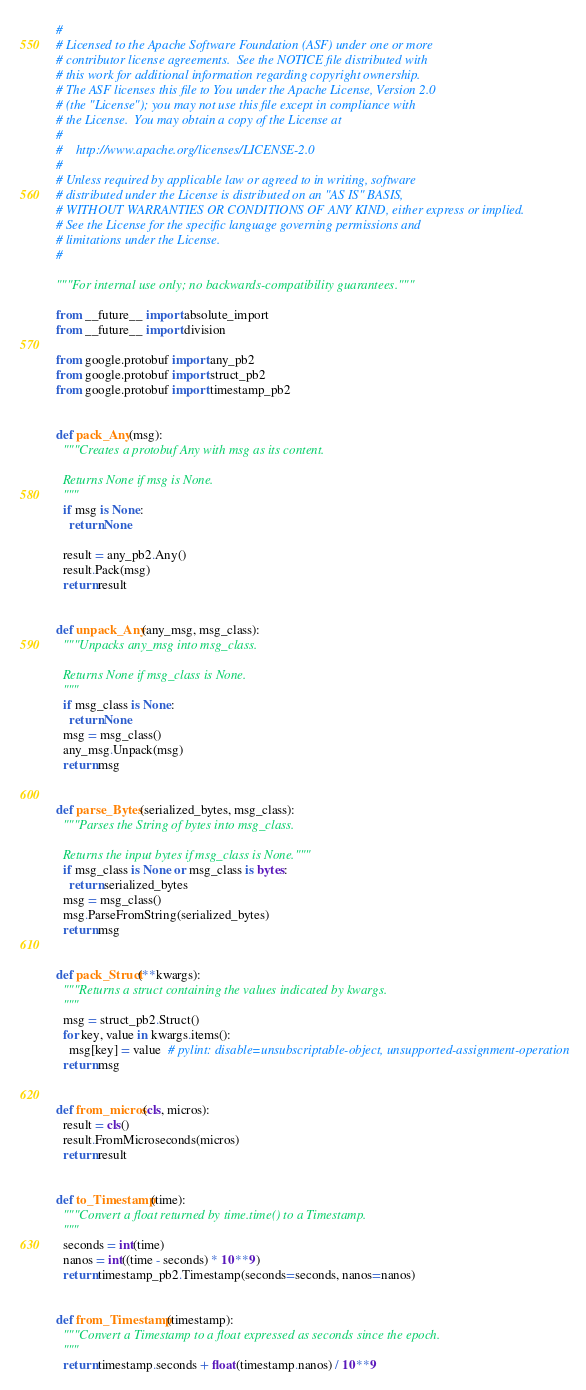<code> <loc_0><loc_0><loc_500><loc_500><_Python_>#
# Licensed to the Apache Software Foundation (ASF) under one or more
# contributor license agreements.  See the NOTICE file distributed with
# this work for additional information regarding copyright ownership.
# The ASF licenses this file to You under the Apache License, Version 2.0
# (the "License"); you may not use this file except in compliance with
# the License.  You may obtain a copy of the License at
#
#    http://www.apache.org/licenses/LICENSE-2.0
#
# Unless required by applicable law or agreed to in writing, software
# distributed under the License is distributed on an "AS IS" BASIS,
# WITHOUT WARRANTIES OR CONDITIONS OF ANY KIND, either express or implied.
# See the License for the specific language governing permissions and
# limitations under the License.
#

"""For internal use only; no backwards-compatibility guarantees."""

from __future__ import absolute_import
from __future__ import division

from google.protobuf import any_pb2
from google.protobuf import struct_pb2
from google.protobuf import timestamp_pb2


def pack_Any(msg):
  """Creates a protobuf Any with msg as its content.

  Returns None if msg is None.
  """
  if msg is None:
    return None

  result = any_pb2.Any()
  result.Pack(msg)
  return result


def unpack_Any(any_msg, msg_class):
  """Unpacks any_msg into msg_class.

  Returns None if msg_class is None.
  """
  if msg_class is None:
    return None
  msg = msg_class()
  any_msg.Unpack(msg)
  return msg


def parse_Bytes(serialized_bytes, msg_class):
  """Parses the String of bytes into msg_class.

  Returns the input bytes if msg_class is None."""
  if msg_class is None or msg_class is bytes:
    return serialized_bytes
  msg = msg_class()
  msg.ParseFromString(serialized_bytes)
  return msg


def pack_Struct(**kwargs):
  """Returns a struct containing the values indicated by kwargs.
  """
  msg = struct_pb2.Struct()
  for key, value in kwargs.items():
    msg[key] = value  # pylint: disable=unsubscriptable-object, unsupported-assignment-operation
  return msg


def from_micros(cls, micros):
  result = cls()
  result.FromMicroseconds(micros)
  return result


def to_Timestamp(time):
  """Convert a float returned by time.time() to a Timestamp.
  """
  seconds = int(time)
  nanos = int((time - seconds) * 10**9)
  return timestamp_pb2.Timestamp(seconds=seconds, nanos=nanos)


def from_Timestamp(timestamp):
  """Convert a Timestamp to a float expressed as seconds since the epoch.
  """
  return timestamp.seconds + float(timestamp.nanos) / 10**9
</code> 